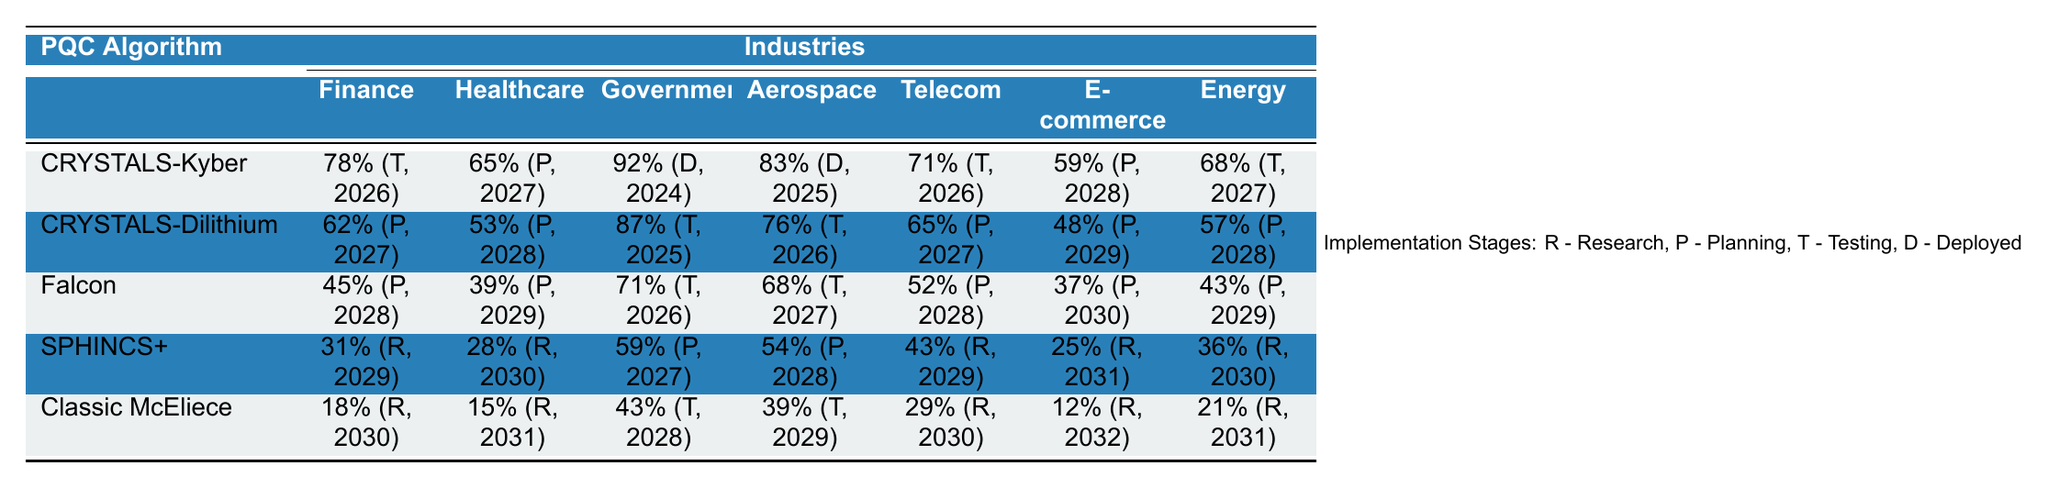What is the highest adoption rate for "CRYSTALS-Kyber" in any industry? The highest adoption rate for "CRYSTALS-Kyber" is 92%, which is in the Government industry.
Answer: 92% Which industry shows the lowest projected full adoption year for "Classic McEliece"? The industry that shows the lowest projected full adoption year for "Classic McEliece" is Finance, projected for 2030.
Answer: 2030 What is the average adoption rate for "Falcon" across all industries? The adoption rates for "Falcon" are 45%, 39%, 71%, 68%, 52%, 37%, and 43%. The sum of these rates is 395. There are 7 data points, so the average is 395/7 = 56.43.
Answer: 56.43 Is "Telecommunications" expecting to have any algorithm fully adopted by 2025? No, "Telecommunications" does not have any algorithm projected for full adoption by 2025; the earliest is 2026 for "CRYSTALS-Dilithium".
Answer: No Which technology has the highest average adoption rate across the industries listed? To find the technology with the highest average, we calculate averages: "CRYSTALS-Kyber" (78 + 65 + 92 + 83 + 71 + 59 + 68) / 7 = 74.57, "CRYSTALS-Dilithium" (62 + 53 + 87 + 76 + 65 + 48 + 57) / 7 = 61.43, "Falcon" (45 + 39 + 71 + 68 + 52 + 37 + 43) / 7 = 49, "SPHINCS+" (31 + 28 + 59 + 54 + 43 + 25 + 36) / 7 = 38.14, "Classic McEliece" (18 + 15 + 43 + 39 + 29 + 12 + 21) / 7 = 22.14. The highest is "CRYSTALS-Kyber" at 74.57.
Answer: CRYSTALS-Kyber How many industries have a higher adoption rate for "CRYSTALS-Kyber" compared to "Classic McEliece"? For "CRYSTALS-Kyber," the adoption rates are 78%, 65%, 92%, 83%, 71%, 59%, and 68%. For "Classic McEliece," they are 18%, 15%, 43%, 39%, 29%, 12%, and 21%. The industries where "CRYSTALS-Kyber" rates are higher are all of them (6).
Answer: 6 Which PQC algorithm has the largest gap between its rates in Finance and E-commerce? We find the rates: "CRYSTALS-Kyber" has a gap of 19% (78% - 59%), "CRYSTALS-Dilithium" has a gap of 14% (62% - 48%), "Falcon" has a gap of 8% (45% - 37%), "SPHINCS+" has a gap of 6% (31% - 25%), and "Classic McEliece" has a gap of 6% (18% - 12%). The largest gap is for "CRYSTALS-Kyber" with a difference of 19%.
Answer: CRYSTALS-Kyber What percentage of the Healthcare industry is in the testing stage across all the algorithms? The testing stages for Healthcare are "CRYSTALS-Kyber" (0%), "CRYSTALS-Dilithium" (0%), "Falcon" (0%), "SPHINCS+" (0%), and "Classic McEliece" (0%). All algorithms have 0% currently in the testing stage.
Answer: 0% 